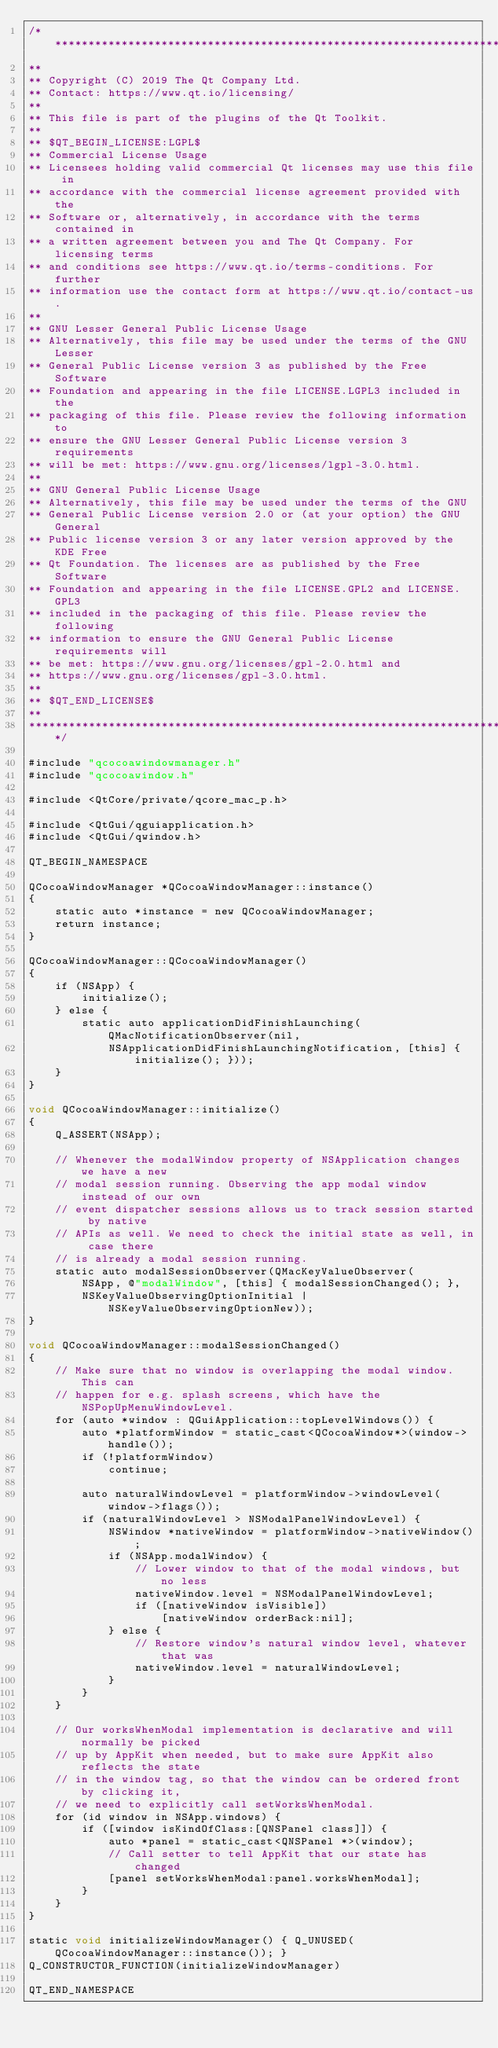<code> <loc_0><loc_0><loc_500><loc_500><_ObjectiveC_>/****************************************************************************
**
** Copyright (C) 2019 The Qt Company Ltd.
** Contact: https://www.qt.io/licensing/
**
** This file is part of the plugins of the Qt Toolkit.
**
** $QT_BEGIN_LICENSE:LGPL$
** Commercial License Usage
** Licensees holding valid commercial Qt licenses may use this file in
** accordance with the commercial license agreement provided with the
** Software or, alternatively, in accordance with the terms contained in
** a written agreement between you and The Qt Company. For licensing terms
** and conditions see https://www.qt.io/terms-conditions. For further
** information use the contact form at https://www.qt.io/contact-us.
**
** GNU Lesser General Public License Usage
** Alternatively, this file may be used under the terms of the GNU Lesser
** General Public License version 3 as published by the Free Software
** Foundation and appearing in the file LICENSE.LGPL3 included in the
** packaging of this file. Please review the following information to
** ensure the GNU Lesser General Public License version 3 requirements
** will be met: https://www.gnu.org/licenses/lgpl-3.0.html.
**
** GNU General Public License Usage
** Alternatively, this file may be used under the terms of the GNU
** General Public License version 2.0 or (at your option) the GNU General
** Public license version 3 or any later version approved by the KDE Free
** Qt Foundation. The licenses are as published by the Free Software
** Foundation and appearing in the file LICENSE.GPL2 and LICENSE.GPL3
** included in the packaging of this file. Please review the following
** information to ensure the GNU General Public License requirements will
** be met: https://www.gnu.org/licenses/gpl-2.0.html and
** https://www.gnu.org/licenses/gpl-3.0.html.
**
** $QT_END_LICENSE$
**
****************************************************************************/

#include "qcocoawindowmanager.h"
#include "qcocoawindow.h"

#include <QtCore/private/qcore_mac_p.h>

#include <QtGui/qguiapplication.h>
#include <QtGui/qwindow.h>

QT_BEGIN_NAMESPACE

QCocoaWindowManager *QCocoaWindowManager::instance()
{
    static auto *instance = new QCocoaWindowManager;
    return instance;
}

QCocoaWindowManager::QCocoaWindowManager()
{
    if (NSApp) {
        initialize();
    } else {
        static auto applicationDidFinishLaunching(QMacNotificationObserver(nil,
            NSApplicationDidFinishLaunchingNotification, [this] { initialize(); }));
    }
}

void QCocoaWindowManager::initialize()
{
    Q_ASSERT(NSApp);

    // Whenever the modalWindow property of NSApplication changes we have a new
    // modal session running. Observing the app modal window instead of our own
    // event dispatcher sessions allows us to track session started by native
    // APIs as well. We need to check the initial state as well, in case there
    // is already a modal session running.
    static auto modalSessionObserver(QMacKeyValueObserver(
        NSApp, @"modalWindow", [this] { modalSessionChanged(); },
        NSKeyValueObservingOptionInitial | NSKeyValueObservingOptionNew));
}

void QCocoaWindowManager::modalSessionChanged()
{
    // Make sure that no window is overlapping the modal window. This can
    // happen for e.g. splash screens, which have the NSPopUpMenuWindowLevel.
    for (auto *window : QGuiApplication::topLevelWindows()) {
        auto *platformWindow = static_cast<QCocoaWindow*>(window->handle());
        if (!platformWindow)
            continue;

        auto naturalWindowLevel = platformWindow->windowLevel(window->flags());
        if (naturalWindowLevel > NSModalPanelWindowLevel) {
            NSWindow *nativeWindow = platformWindow->nativeWindow();
            if (NSApp.modalWindow) {
                // Lower window to that of the modal windows, but no less
                nativeWindow.level = NSModalPanelWindowLevel;
                if ([nativeWindow isVisible])
                    [nativeWindow orderBack:nil];
            } else {
                // Restore window's natural window level, whatever that was
                nativeWindow.level = naturalWindowLevel;
            }
        }
    }

    // Our worksWhenModal implementation is declarative and will normally be picked
    // up by AppKit when needed, but to make sure AppKit also reflects the state
    // in the window tag, so that the window can be ordered front by clicking it,
    // we need to explicitly call setWorksWhenModal.
    for (id window in NSApp.windows) {
        if ([window isKindOfClass:[QNSPanel class]]) {
            auto *panel = static_cast<QNSPanel *>(window);
            // Call setter to tell AppKit that our state has changed
            [panel setWorksWhenModal:panel.worksWhenModal];
        }
    }
}

static void initializeWindowManager() { Q_UNUSED(QCocoaWindowManager::instance()); }
Q_CONSTRUCTOR_FUNCTION(initializeWindowManager)

QT_END_NAMESPACE

</code> 